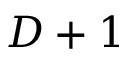Convert formula to latex. <formula><loc_0><loc_0><loc_500><loc_500>D + 1</formula> 